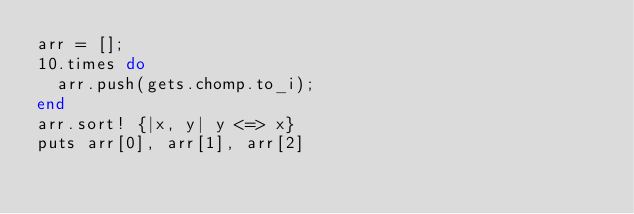<code> <loc_0><loc_0><loc_500><loc_500><_Ruby_>arr = [];
10.times do
  arr.push(gets.chomp.to_i);
end
arr.sort! {|x, y| y <=> x}
puts arr[0], arr[1], arr[2]</code> 